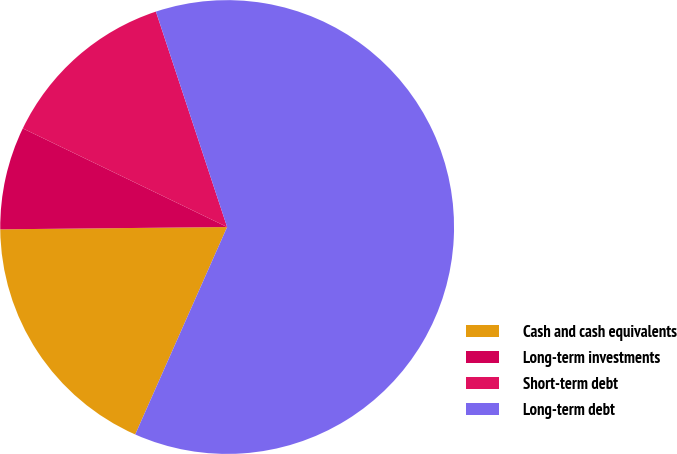Convert chart to OTSL. <chart><loc_0><loc_0><loc_500><loc_500><pie_chart><fcel>Cash and cash equivalents<fcel>Long-term investments<fcel>Short-term debt<fcel>Long-term debt<nl><fcel>18.2%<fcel>7.32%<fcel>12.76%<fcel>61.72%<nl></chart> 